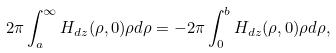Convert formula to latex. <formula><loc_0><loc_0><loc_500><loc_500>2 \pi \int _ { a } ^ { \infty } H _ { d z } ( \rho , 0 ) \rho d \rho = - 2 \pi \int _ { 0 } ^ { b } H _ { d z } ( \rho , 0 ) \rho d \rho ,</formula> 